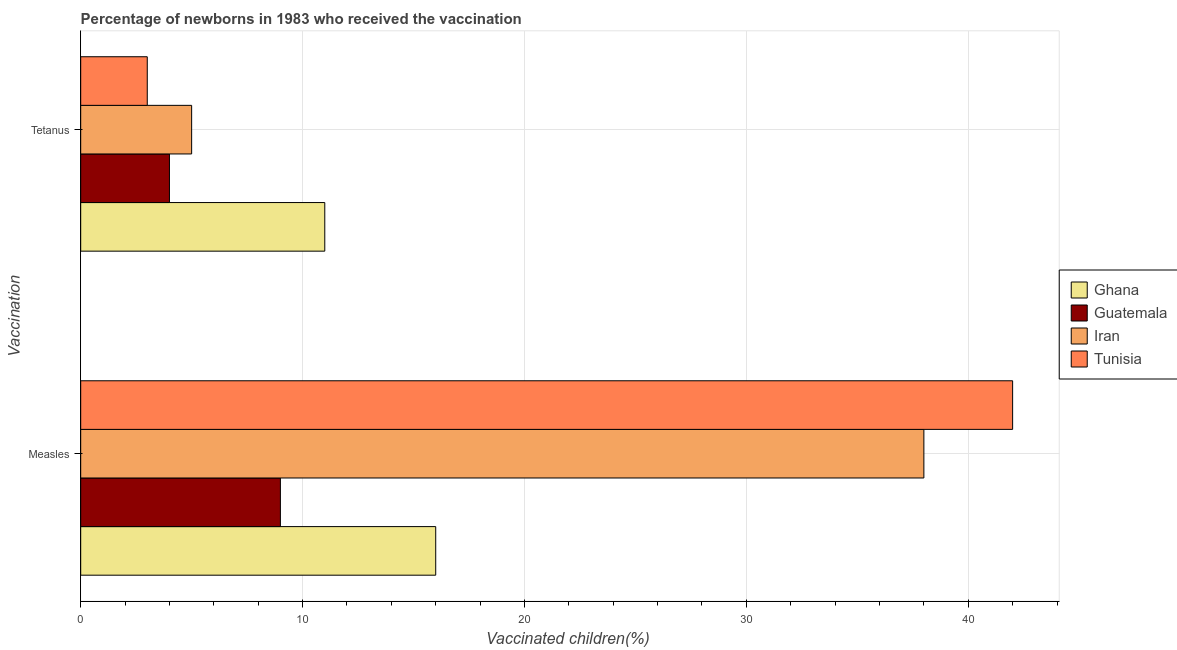Are the number of bars on each tick of the Y-axis equal?
Provide a succinct answer. Yes. How many bars are there on the 2nd tick from the top?
Give a very brief answer. 4. What is the label of the 1st group of bars from the top?
Your response must be concise. Tetanus. What is the percentage of newborns who received vaccination for tetanus in Ghana?
Provide a short and direct response. 11. Across all countries, what is the maximum percentage of newborns who received vaccination for tetanus?
Offer a very short reply. 11. Across all countries, what is the minimum percentage of newborns who received vaccination for tetanus?
Provide a succinct answer. 3. In which country was the percentage of newborns who received vaccination for tetanus minimum?
Offer a very short reply. Tunisia. What is the total percentage of newborns who received vaccination for measles in the graph?
Give a very brief answer. 105. What is the difference between the percentage of newborns who received vaccination for measles in Ghana and that in Iran?
Your answer should be very brief. -22. What is the difference between the percentage of newborns who received vaccination for tetanus in Ghana and the percentage of newborns who received vaccination for measles in Tunisia?
Your answer should be compact. -31. What is the average percentage of newborns who received vaccination for measles per country?
Provide a short and direct response. 26.25. What is the difference between the percentage of newborns who received vaccination for measles and percentage of newborns who received vaccination for tetanus in Tunisia?
Give a very brief answer. 39. What is the ratio of the percentage of newborns who received vaccination for tetanus in Ghana to that in Guatemala?
Your answer should be very brief. 2.75. Is the percentage of newborns who received vaccination for measles in Iran less than that in Ghana?
Keep it short and to the point. No. What does the 3rd bar from the top in Tetanus represents?
Keep it short and to the point. Guatemala. What does the 2nd bar from the bottom in Tetanus represents?
Offer a very short reply. Guatemala. Are all the bars in the graph horizontal?
Keep it short and to the point. Yes. Are the values on the major ticks of X-axis written in scientific E-notation?
Your answer should be compact. No. Does the graph contain any zero values?
Your answer should be very brief. No. Does the graph contain grids?
Provide a short and direct response. Yes. Where does the legend appear in the graph?
Give a very brief answer. Center right. What is the title of the graph?
Your answer should be compact. Percentage of newborns in 1983 who received the vaccination. What is the label or title of the X-axis?
Provide a succinct answer. Vaccinated children(%)
. What is the label or title of the Y-axis?
Provide a short and direct response. Vaccination. What is the Vaccinated children(%)
 of Guatemala in Measles?
Provide a succinct answer. 9. What is the Vaccinated children(%)
 of Iran in Measles?
Give a very brief answer. 38. What is the Vaccinated children(%)
 of Iran in Tetanus?
Make the answer very short. 5. Across all Vaccination, what is the maximum Vaccinated children(%)
 in Ghana?
Offer a terse response. 16. Across all Vaccination, what is the maximum Vaccinated children(%)
 of Guatemala?
Offer a terse response. 9. Across all Vaccination, what is the maximum Vaccinated children(%)
 of Tunisia?
Your response must be concise. 42. Across all Vaccination, what is the minimum Vaccinated children(%)
 in Ghana?
Offer a terse response. 11. Across all Vaccination, what is the minimum Vaccinated children(%)
 in Iran?
Provide a short and direct response. 5. Across all Vaccination, what is the minimum Vaccinated children(%)
 in Tunisia?
Your response must be concise. 3. What is the total Vaccinated children(%)
 in Ghana in the graph?
Your answer should be compact. 27. What is the total Vaccinated children(%)
 in Iran in the graph?
Ensure brevity in your answer.  43. What is the total Vaccinated children(%)
 in Tunisia in the graph?
Offer a terse response. 45. What is the difference between the Vaccinated children(%)
 in Ghana in Measles and that in Tetanus?
Provide a succinct answer. 5. What is the difference between the Vaccinated children(%)
 of Guatemala in Measles and that in Tetanus?
Provide a short and direct response. 5. What is the difference between the Vaccinated children(%)
 of Iran in Measles and that in Tetanus?
Your answer should be very brief. 33. What is the difference between the Vaccinated children(%)
 in Tunisia in Measles and that in Tetanus?
Make the answer very short. 39. What is the difference between the Vaccinated children(%)
 of Ghana in Measles and the Vaccinated children(%)
 of Iran in Tetanus?
Your answer should be very brief. 11. What is the difference between the Vaccinated children(%)
 in Ghana in Measles and the Vaccinated children(%)
 in Tunisia in Tetanus?
Offer a very short reply. 13. What is the difference between the Vaccinated children(%)
 of Guatemala in Measles and the Vaccinated children(%)
 of Iran in Tetanus?
Give a very brief answer. 4. What is the difference between the Vaccinated children(%)
 in Iran in Measles and the Vaccinated children(%)
 in Tunisia in Tetanus?
Your response must be concise. 35. What is the average Vaccinated children(%)
 of Guatemala per Vaccination?
Ensure brevity in your answer.  6.5. What is the difference between the Vaccinated children(%)
 of Ghana and Vaccinated children(%)
 of Guatemala in Measles?
Keep it short and to the point. 7. What is the difference between the Vaccinated children(%)
 of Ghana and Vaccinated children(%)
 of Iran in Measles?
Provide a short and direct response. -22. What is the difference between the Vaccinated children(%)
 in Ghana and Vaccinated children(%)
 in Tunisia in Measles?
Ensure brevity in your answer.  -26. What is the difference between the Vaccinated children(%)
 of Guatemala and Vaccinated children(%)
 of Tunisia in Measles?
Your response must be concise. -33. What is the difference between the Vaccinated children(%)
 of Ghana and Vaccinated children(%)
 of Tunisia in Tetanus?
Provide a short and direct response. 8. What is the difference between the Vaccinated children(%)
 of Guatemala and Vaccinated children(%)
 of Iran in Tetanus?
Your response must be concise. -1. What is the ratio of the Vaccinated children(%)
 of Ghana in Measles to that in Tetanus?
Keep it short and to the point. 1.45. What is the ratio of the Vaccinated children(%)
 of Guatemala in Measles to that in Tetanus?
Provide a short and direct response. 2.25. What is the ratio of the Vaccinated children(%)
 in Tunisia in Measles to that in Tetanus?
Your answer should be compact. 14. What is the difference between the highest and the second highest Vaccinated children(%)
 of Ghana?
Provide a short and direct response. 5. What is the difference between the highest and the second highest Vaccinated children(%)
 in Guatemala?
Keep it short and to the point. 5. What is the difference between the highest and the lowest Vaccinated children(%)
 in Ghana?
Ensure brevity in your answer.  5. What is the difference between the highest and the lowest Vaccinated children(%)
 of Guatemala?
Make the answer very short. 5. What is the difference between the highest and the lowest Vaccinated children(%)
 in Iran?
Keep it short and to the point. 33. What is the difference between the highest and the lowest Vaccinated children(%)
 of Tunisia?
Your answer should be compact. 39. 